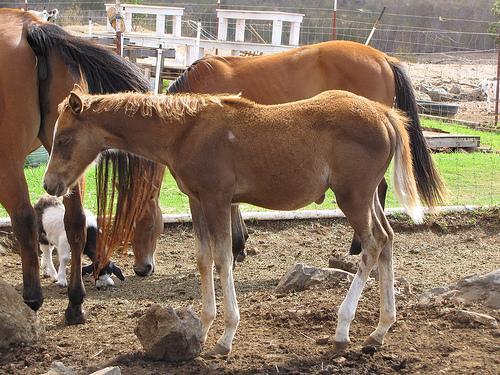How many dogs are in the picture?
Give a very brief answer. 1. 